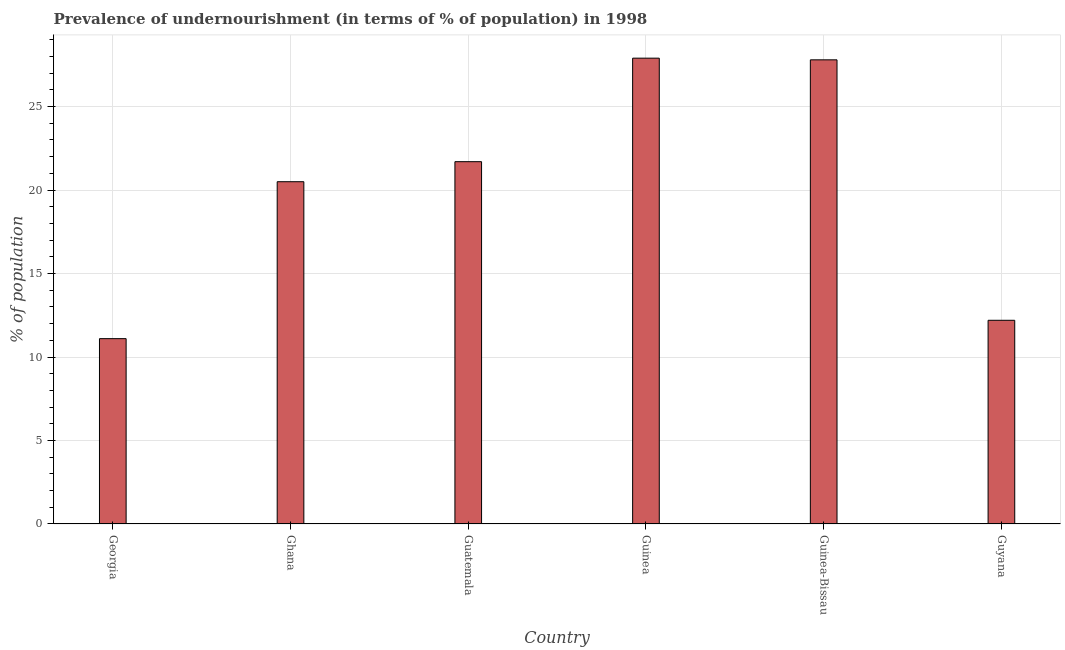Does the graph contain grids?
Offer a terse response. Yes. What is the title of the graph?
Give a very brief answer. Prevalence of undernourishment (in terms of % of population) in 1998. What is the label or title of the X-axis?
Offer a terse response. Country. What is the label or title of the Y-axis?
Keep it short and to the point. % of population. Across all countries, what is the maximum percentage of undernourished population?
Give a very brief answer. 27.9. In which country was the percentage of undernourished population maximum?
Keep it short and to the point. Guinea. In which country was the percentage of undernourished population minimum?
Your answer should be very brief. Georgia. What is the sum of the percentage of undernourished population?
Make the answer very short. 121.2. What is the average percentage of undernourished population per country?
Offer a very short reply. 20.2. What is the median percentage of undernourished population?
Make the answer very short. 21.1. What is the ratio of the percentage of undernourished population in Ghana to that in Guinea-Bissau?
Give a very brief answer. 0.74. Is the sum of the percentage of undernourished population in Ghana and Guinea greater than the maximum percentage of undernourished population across all countries?
Offer a terse response. Yes. In how many countries, is the percentage of undernourished population greater than the average percentage of undernourished population taken over all countries?
Make the answer very short. 4. What is the % of population of Georgia?
Give a very brief answer. 11.1. What is the % of population in Ghana?
Offer a very short reply. 20.5. What is the % of population of Guatemala?
Your answer should be compact. 21.7. What is the % of population in Guinea?
Provide a succinct answer. 27.9. What is the % of population in Guinea-Bissau?
Give a very brief answer. 27.8. What is the % of population in Guyana?
Your answer should be compact. 12.2. What is the difference between the % of population in Georgia and Ghana?
Provide a short and direct response. -9.4. What is the difference between the % of population in Georgia and Guinea?
Offer a very short reply. -16.8. What is the difference between the % of population in Georgia and Guinea-Bissau?
Provide a succinct answer. -16.7. What is the difference between the % of population in Georgia and Guyana?
Offer a terse response. -1.1. What is the difference between the % of population in Ghana and Guinea-Bissau?
Make the answer very short. -7.3. What is the difference between the % of population in Guatemala and Guinea-Bissau?
Provide a short and direct response. -6.1. What is the difference between the % of population in Guinea and Guinea-Bissau?
Offer a terse response. 0.1. What is the difference between the % of population in Guinea and Guyana?
Keep it short and to the point. 15.7. What is the difference between the % of population in Guinea-Bissau and Guyana?
Make the answer very short. 15.6. What is the ratio of the % of population in Georgia to that in Ghana?
Your answer should be very brief. 0.54. What is the ratio of the % of population in Georgia to that in Guatemala?
Give a very brief answer. 0.51. What is the ratio of the % of population in Georgia to that in Guinea?
Ensure brevity in your answer.  0.4. What is the ratio of the % of population in Georgia to that in Guinea-Bissau?
Your answer should be compact. 0.4. What is the ratio of the % of population in Georgia to that in Guyana?
Give a very brief answer. 0.91. What is the ratio of the % of population in Ghana to that in Guatemala?
Offer a very short reply. 0.94. What is the ratio of the % of population in Ghana to that in Guinea?
Give a very brief answer. 0.73. What is the ratio of the % of population in Ghana to that in Guinea-Bissau?
Offer a terse response. 0.74. What is the ratio of the % of population in Ghana to that in Guyana?
Your response must be concise. 1.68. What is the ratio of the % of population in Guatemala to that in Guinea?
Provide a short and direct response. 0.78. What is the ratio of the % of population in Guatemala to that in Guinea-Bissau?
Ensure brevity in your answer.  0.78. What is the ratio of the % of population in Guatemala to that in Guyana?
Ensure brevity in your answer.  1.78. What is the ratio of the % of population in Guinea to that in Guyana?
Your answer should be compact. 2.29. What is the ratio of the % of population in Guinea-Bissau to that in Guyana?
Give a very brief answer. 2.28. 